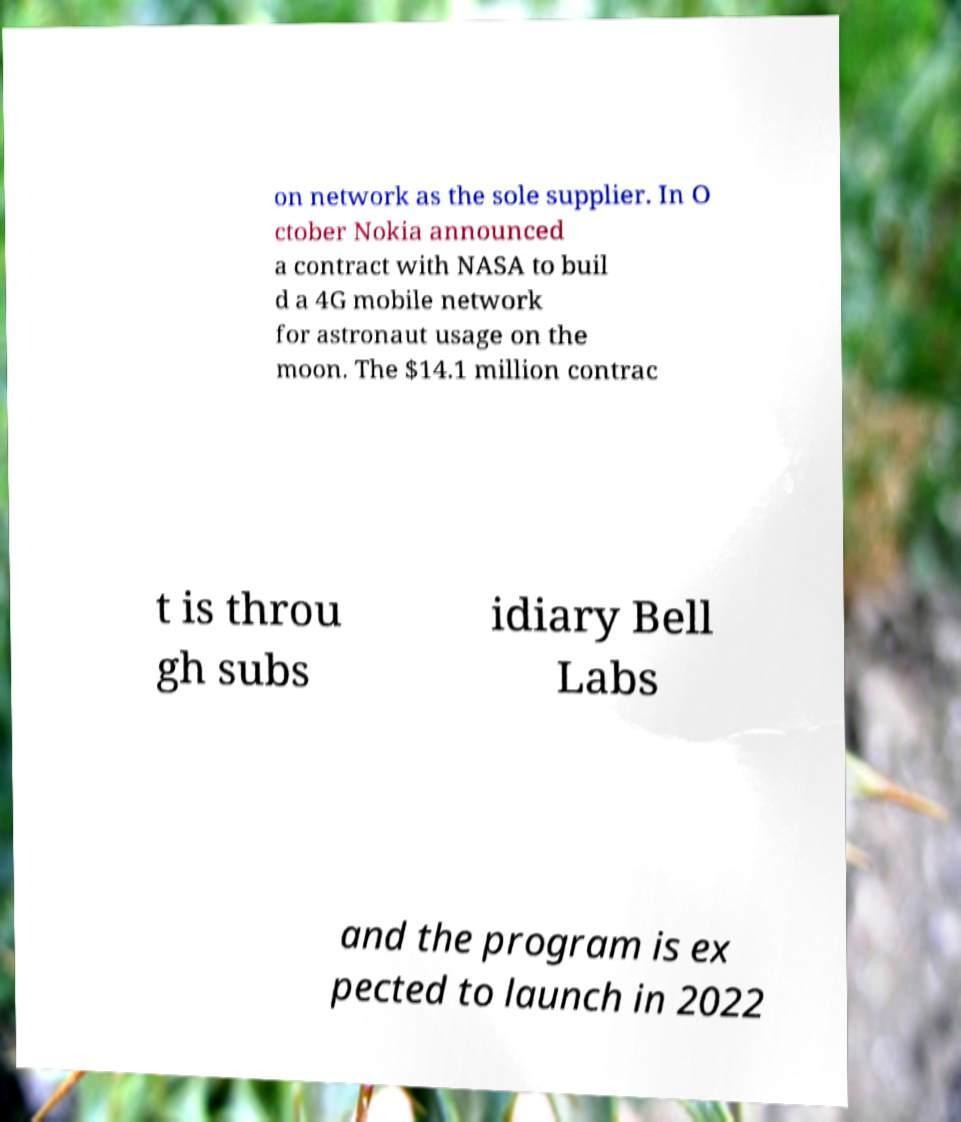What messages or text are displayed in this image? I need them in a readable, typed format. on network as the sole supplier. In O ctober Nokia announced a contract with NASA to buil d a 4G mobile network for astronaut usage on the moon. The $14.1 million contrac t is throu gh subs idiary Bell Labs and the program is ex pected to launch in 2022 